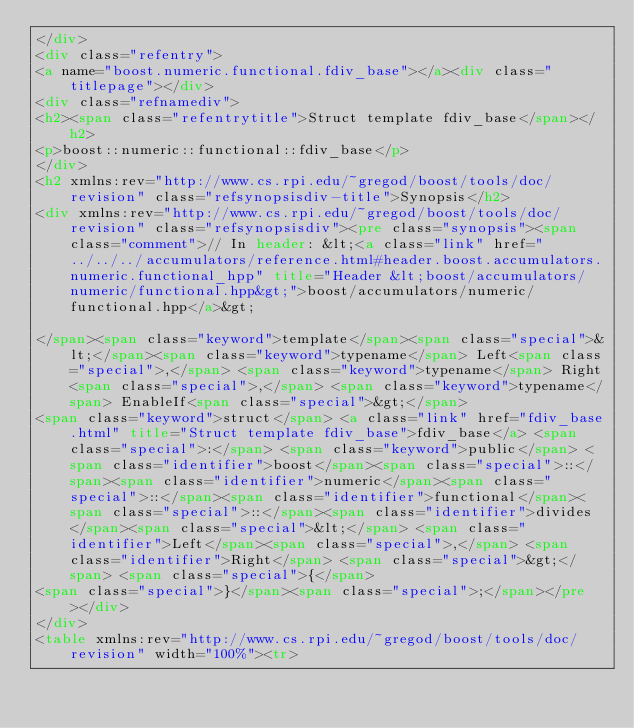Convert code to text. <code><loc_0><loc_0><loc_500><loc_500><_HTML_></div>
<div class="refentry">
<a name="boost.numeric.functional.fdiv_base"></a><div class="titlepage"></div>
<div class="refnamediv">
<h2><span class="refentrytitle">Struct template fdiv_base</span></h2>
<p>boost::numeric::functional::fdiv_base</p>
</div>
<h2 xmlns:rev="http://www.cs.rpi.edu/~gregod/boost/tools/doc/revision" class="refsynopsisdiv-title">Synopsis</h2>
<div xmlns:rev="http://www.cs.rpi.edu/~gregod/boost/tools/doc/revision" class="refsynopsisdiv"><pre class="synopsis"><span class="comment">// In header: &lt;<a class="link" href="../../../accumulators/reference.html#header.boost.accumulators.numeric.functional_hpp" title="Header &lt;boost/accumulators/numeric/functional.hpp&gt;">boost/accumulators/numeric/functional.hpp</a>&gt;

</span><span class="keyword">template</span><span class="special">&lt;</span><span class="keyword">typename</span> Left<span class="special">,</span> <span class="keyword">typename</span> Right<span class="special">,</span> <span class="keyword">typename</span> EnableIf<span class="special">&gt;</span> 
<span class="keyword">struct</span> <a class="link" href="fdiv_base.html" title="Struct template fdiv_base">fdiv_base</a> <span class="special">:</span> <span class="keyword">public</span> <span class="identifier">boost</span><span class="special">::</span><span class="identifier">numeric</span><span class="special">::</span><span class="identifier">functional</span><span class="special">::</span><span class="identifier">divides</span><span class="special">&lt;</span> <span class="identifier">Left</span><span class="special">,</span> <span class="identifier">Right</span> <span class="special">&gt;</span> <span class="special">{</span>
<span class="special">}</span><span class="special">;</span></pre></div>
</div>
<table xmlns:rev="http://www.cs.rpi.edu/~gregod/boost/tools/doc/revision" width="100%"><tr></code> 